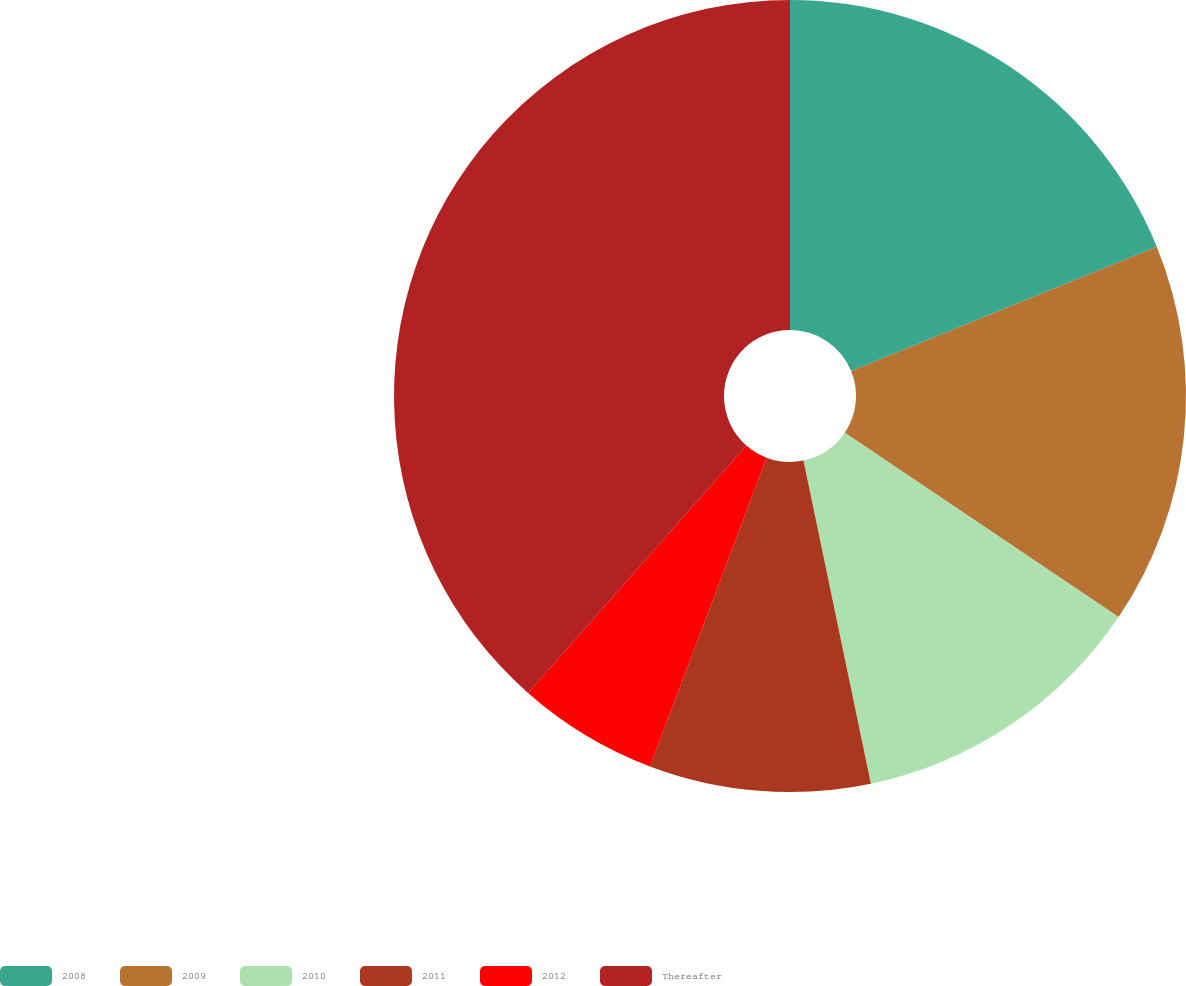Convert chart. <chart><loc_0><loc_0><loc_500><loc_500><pie_chart><fcel>2008<fcel>2009<fcel>2010<fcel>2011<fcel>2012<fcel>Thereafter<nl><fcel>18.85%<fcel>15.58%<fcel>12.3%<fcel>9.03%<fcel>5.75%<fcel>38.5%<nl></chart> 